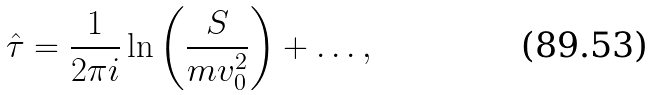<formula> <loc_0><loc_0><loc_500><loc_500>\hat { \tau } = \frac { 1 } { 2 \pi i } \ln \left ( \frac { S } { m v _ { 0 } ^ { 2 } } \right ) + \dots ,</formula> 